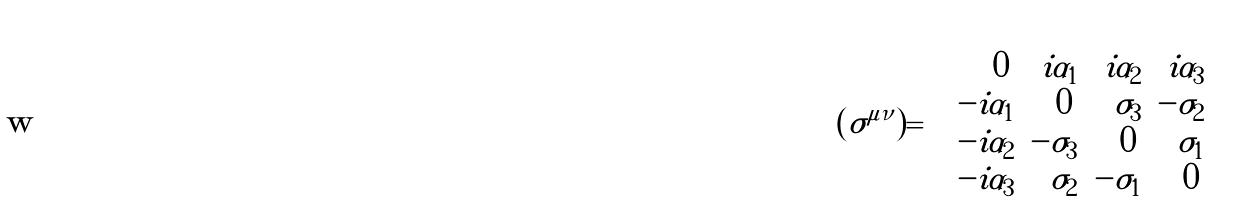<formula> <loc_0><loc_0><loc_500><loc_500>( \sigma ^ { \mu \nu } ) = \left ( \begin{array} { r r r r } 0 \, & i \alpha _ { 1 } & i \alpha _ { 2 } & i \alpha _ { 3 } \\ - i \alpha _ { 1 } & 0 \, & \sigma _ { 3 } & - \sigma _ { 2 } \\ - i \alpha _ { 2 } & - \sigma _ { 3 } & 0 \, & \sigma _ { 1 } \\ - i \alpha _ { 3 } & \sigma _ { 2 } & - \sigma _ { 1 } & 0 \, \end{array} \right )</formula> 